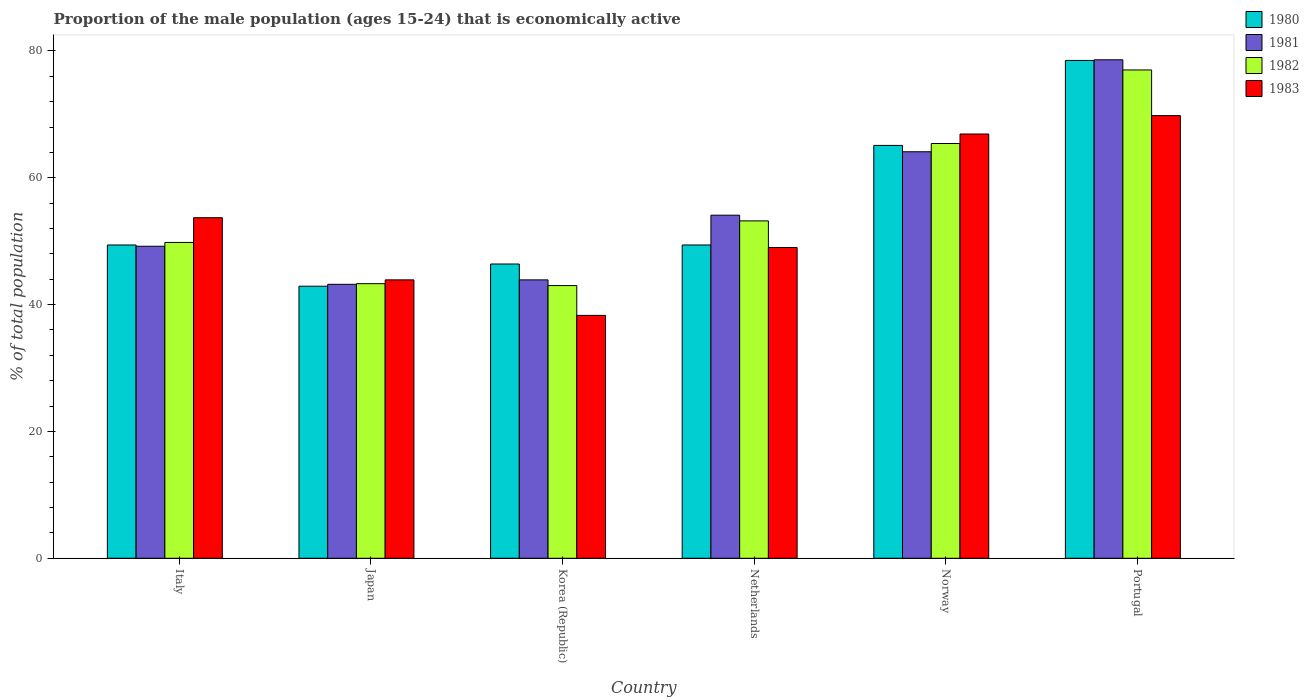How many different coloured bars are there?
Your response must be concise. 4. How many groups of bars are there?
Your answer should be very brief. 6. Are the number of bars per tick equal to the number of legend labels?
Your answer should be very brief. Yes. How many bars are there on the 5th tick from the left?
Provide a short and direct response. 4. How many bars are there on the 1st tick from the right?
Keep it short and to the point. 4. What is the label of the 4th group of bars from the left?
Provide a short and direct response. Netherlands. What is the proportion of the male population that is economically active in 1983 in Korea (Republic)?
Your answer should be very brief. 38.3. Across all countries, what is the maximum proportion of the male population that is economically active in 1982?
Ensure brevity in your answer.  77. Across all countries, what is the minimum proportion of the male population that is economically active in 1981?
Give a very brief answer. 43.2. In which country was the proportion of the male population that is economically active in 1983 maximum?
Offer a very short reply. Portugal. What is the total proportion of the male population that is economically active in 1980 in the graph?
Give a very brief answer. 331.7. What is the difference between the proportion of the male population that is economically active in 1983 in Italy and that in Netherlands?
Provide a succinct answer. 4.7. What is the difference between the proportion of the male population that is economically active in 1981 in Norway and the proportion of the male population that is economically active in 1980 in Netherlands?
Offer a very short reply. 14.7. What is the average proportion of the male population that is economically active in 1981 per country?
Your answer should be very brief. 55.52. What is the difference between the proportion of the male population that is economically active of/in 1981 and proportion of the male population that is economically active of/in 1980 in Portugal?
Give a very brief answer. 0.1. What is the ratio of the proportion of the male population that is economically active in 1983 in Netherlands to that in Portugal?
Provide a short and direct response. 0.7. Is the proportion of the male population that is economically active in 1981 in Netherlands less than that in Norway?
Offer a very short reply. Yes. What is the difference between the highest and the second highest proportion of the male population that is economically active in 1982?
Make the answer very short. 12.2. In how many countries, is the proportion of the male population that is economically active in 1983 greater than the average proportion of the male population that is economically active in 1983 taken over all countries?
Keep it short and to the point. 3. Is the sum of the proportion of the male population that is economically active in 1981 in Italy and Portugal greater than the maximum proportion of the male population that is economically active in 1980 across all countries?
Ensure brevity in your answer.  Yes. What does the 1st bar from the right in Norway represents?
Give a very brief answer. 1983. Is it the case that in every country, the sum of the proportion of the male population that is economically active in 1982 and proportion of the male population that is economically active in 1980 is greater than the proportion of the male population that is economically active in 1981?
Offer a very short reply. Yes. Are all the bars in the graph horizontal?
Make the answer very short. No. What is the difference between two consecutive major ticks on the Y-axis?
Provide a short and direct response. 20. Where does the legend appear in the graph?
Your answer should be very brief. Top right. What is the title of the graph?
Make the answer very short. Proportion of the male population (ages 15-24) that is economically active. Does "2012" appear as one of the legend labels in the graph?
Give a very brief answer. No. What is the label or title of the X-axis?
Your answer should be very brief. Country. What is the label or title of the Y-axis?
Offer a very short reply. % of total population. What is the % of total population of 1980 in Italy?
Offer a very short reply. 49.4. What is the % of total population in 1981 in Italy?
Offer a very short reply. 49.2. What is the % of total population of 1982 in Italy?
Your answer should be very brief. 49.8. What is the % of total population in 1983 in Italy?
Ensure brevity in your answer.  53.7. What is the % of total population in 1980 in Japan?
Provide a succinct answer. 42.9. What is the % of total population in 1981 in Japan?
Ensure brevity in your answer.  43.2. What is the % of total population in 1982 in Japan?
Offer a very short reply. 43.3. What is the % of total population of 1983 in Japan?
Provide a short and direct response. 43.9. What is the % of total population in 1980 in Korea (Republic)?
Your response must be concise. 46.4. What is the % of total population in 1981 in Korea (Republic)?
Ensure brevity in your answer.  43.9. What is the % of total population of 1983 in Korea (Republic)?
Offer a very short reply. 38.3. What is the % of total population in 1980 in Netherlands?
Provide a succinct answer. 49.4. What is the % of total population of 1981 in Netherlands?
Your answer should be compact. 54.1. What is the % of total population in 1982 in Netherlands?
Give a very brief answer. 53.2. What is the % of total population of 1983 in Netherlands?
Your answer should be compact. 49. What is the % of total population in 1980 in Norway?
Offer a terse response. 65.1. What is the % of total population of 1981 in Norway?
Your answer should be compact. 64.1. What is the % of total population of 1982 in Norway?
Your response must be concise. 65.4. What is the % of total population in 1983 in Norway?
Offer a very short reply. 66.9. What is the % of total population in 1980 in Portugal?
Ensure brevity in your answer.  78.5. What is the % of total population in 1981 in Portugal?
Your answer should be very brief. 78.6. What is the % of total population of 1983 in Portugal?
Your response must be concise. 69.8. Across all countries, what is the maximum % of total population in 1980?
Give a very brief answer. 78.5. Across all countries, what is the maximum % of total population in 1981?
Keep it short and to the point. 78.6. Across all countries, what is the maximum % of total population in 1983?
Your answer should be compact. 69.8. Across all countries, what is the minimum % of total population of 1980?
Your answer should be very brief. 42.9. Across all countries, what is the minimum % of total population in 1981?
Your answer should be compact. 43.2. Across all countries, what is the minimum % of total population of 1982?
Ensure brevity in your answer.  43. Across all countries, what is the minimum % of total population of 1983?
Ensure brevity in your answer.  38.3. What is the total % of total population of 1980 in the graph?
Provide a succinct answer. 331.7. What is the total % of total population in 1981 in the graph?
Keep it short and to the point. 333.1. What is the total % of total population of 1982 in the graph?
Give a very brief answer. 331.7. What is the total % of total population of 1983 in the graph?
Your answer should be very brief. 321.6. What is the difference between the % of total population in 1980 in Italy and that in Japan?
Provide a short and direct response. 6.5. What is the difference between the % of total population of 1981 in Italy and that in Japan?
Keep it short and to the point. 6. What is the difference between the % of total population in 1980 in Italy and that in Korea (Republic)?
Offer a terse response. 3. What is the difference between the % of total population in 1981 in Italy and that in Korea (Republic)?
Ensure brevity in your answer.  5.3. What is the difference between the % of total population of 1982 in Italy and that in Korea (Republic)?
Your answer should be very brief. 6.8. What is the difference between the % of total population in 1980 in Italy and that in Netherlands?
Ensure brevity in your answer.  0. What is the difference between the % of total population of 1983 in Italy and that in Netherlands?
Give a very brief answer. 4.7. What is the difference between the % of total population in 1980 in Italy and that in Norway?
Provide a succinct answer. -15.7. What is the difference between the % of total population in 1981 in Italy and that in Norway?
Give a very brief answer. -14.9. What is the difference between the % of total population of 1982 in Italy and that in Norway?
Ensure brevity in your answer.  -15.6. What is the difference between the % of total population of 1980 in Italy and that in Portugal?
Give a very brief answer. -29.1. What is the difference between the % of total population of 1981 in Italy and that in Portugal?
Your answer should be very brief. -29.4. What is the difference between the % of total population in 1982 in Italy and that in Portugal?
Give a very brief answer. -27.2. What is the difference between the % of total population of 1983 in Italy and that in Portugal?
Your answer should be compact. -16.1. What is the difference between the % of total population in 1980 in Japan and that in Korea (Republic)?
Provide a short and direct response. -3.5. What is the difference between the % of total population in 1982 in Japan and that in Korea (Republic)?
Offer a very short reply. 0.3. What is the difference between the % of total population in 1983 in Japan and that in Korea (Republic)?
Make the answer very short. 5.6. What is the difference between the % of total population of 1981 in Japan and that in Netherlands?
Provide a short and direct response. -10.9. What is the difference between the % of total population of 1983 in Japan and that in Netherlands?
Provide a succinct answer. -5.1. What is the difference between the % of total population of 1980 in Japan and that in Norway?
Keep it short and to the point. -22.2. What is the difference between the % of total population in 1981 in Japan and that in Norway?
Make the answer very short. -20.9. What is the difference between the % of total population of 1982 in Japan and that in Norway?
Provide a succinct answer. -22.1. What is the difference between the % of total population of 1983 in Japan and that in Norway?
Offer a very short reply. -23. What is the difference between the % of total population of 1980 in Japan and that in Portugal?
Ensure brevity in your answer.  -35.6. What is the difference between the % of total population of 1981 in Japan and that in Portugal?
Make the answer very short. -35.4. What is the difference between the % of total population in 1982 in Japan and that in Portugal?
Make the answer very short. -33.7. What is the difference between the % of total population in 1983 in Japan and that in Portugal?
Make the answer very short. -25.9. What is the difference between the % of total population in 1981 in Korea (Republic) and that in Netherlands?
Offer a very short reply. -10.2. What is the difference between the % of total population in 1982 in Korea (Republic) and that in Netherlands?
Offer a very short reply. -10.2. What is the difference between the % of total population in 1983 in Korea (Republic) and that in Netherlands?
Offer a terse response. -10.7. What is the difference between the % of total population in 1980 in Korea (Republic) and that in Norway?
Ensure brevity in your answer.  -18.7. What is the difference between the % of total population in 1981 in Korea (Republic) and that in Norway?
Your answer should be compact. -20.2. What is the difference between the % of total population in 1982 in Korea (Republic) and that in Norway?
Offer a terse response. -22.4. What is the difference between the % of total population in 1983 in Korea (Republic) and that in Norway?
Ensure brevity in your answer.  -28.6. What is the difference between the % of total population in 1980 in Korea (Republic) and that in Portugal?
Provide a short and direct response. -32.1. What is the difference between the % of total population of 1981 in Korea (Republic) and that in Portugal?
Keep it short and to the point. -34.7. What is the difference between the % of total population in 1982 in Korea (Republic) and that in Portugal?
Ensure brevity in your answer.  -34. What is the difference between the % of total population of 1983 in Korea (Republic) and that in Portugal?
Ensure brevity in your answer.  -31.5. What is the difference between the % of total population of 1980 in Netherlands and that in Norway?
Your answer should be very brief. -15.7. What is the difference between the % of total population of 1981 in Netherlands and that in Norway?
Provide a short and direct response. -10. What is the difference between the % of total population of 1982 in Netherlands and that in Norway?
Your response must be concise. -12.2. What is the difference between the % of total population of 1983 in Netherlands and that in Norway?
Keep it short and to the point. -17.9. What is the difference between the % of total population of 1980 in Netherlands and that in Portugal?
Make the answer very short. -29.1. What is the difference between the % of total population in 1981 in Netherlands and that in Portugal?
Provide a succinct answer. -24.5. What is the difference between the % of total population in 1982 in Netherlands and that in Portugal?
Provide a succinct answer. -23.8. What is the difference between the % of total population of 1983 in Netherlands and that in Portugal?
Provide a short and direct response. -20.8. What is the difference between the % of total population in 1980 in Norway and that in Portugal?
Your response must be concise. -13.4. What is the difference between the % of total population of 1981 in Norway and that in Portugal?
Ensure brevity in your answer.  -14.5. What is the difference between the % of total population in 1982 in Norway and that in Portugal?
Your answer should be very brief. -11.6. What is the difference between the % of total population in 1983 in Norway and that in Portugal?
Keep it short and to the point. -2.9. What is the difference between the % of total population of 1980 in Italy and the % of total population of 1981 in Japan?
Offer a terse response. 6.2. What is the difference between the % of total population of 1980 in Italy and the % of total population of 1982 in Japan?
Your answer should be very brief. 6.1. What is the difference between the % of total population of 1981 in Italy and the % of total population of 1982 in Japan?
Offer a very short reply. 5.9. What is the difference between the % of total population in 1980 in Italy and the % of total population in 1981 in Korea (Republic)?
Keep it short and to the point. 5.5. What is the difference between the % of total population in 1980 in Italy and the % of total population in 1983 in Korea (Republic)?
Your answer should be compact. 11.1. What is the difference between the % of total population in 1981 in Italy and the % of total population in 1982 in Korea (Republic)?
Your response must be concise. 6.2. What is the difference between the % of total population of 1980 in Italy and the % of total population of 1981 in Netherlands?
Provide a succinct answer. -4.7. What is the difference between the % of total population in 1980 in Italy and the % of total population in 1982 in Netherlands?
Offer a terse response. -3.8. What is the difference between the % of total population of 1981 in Italy and the % of total population of 1982 in Netherlands?
Your answer should be very brief. -4. What is the difference between the % of total population of 1982 in Italy and the % of total population of 1983 in Netherlands?
Your answer should be very brief. 0.8. What is the difference between the % of total population of 1980 in Italy and the % of total population of 1981 in Norway?
Your answer should be compact. -14.7. What is the difference between the % of total population of 1980 in Italy and the % of total population of 1982 in Norway?
Keep it short and to the point. -16. What is the difference between the % of total population in 1980 in Italy and the % of total population in 1983 in Norway?
Provide a short and direct response. -17.5. What is the difference between the % of total population in 1981 in Italy and the % of total population in 1982 in Norway?
Your answer should be compact. -16.2. What is the difference between the % of total population of 1981 in Italy and the % of total population of 1983 in Norway?
Provide a succinct answer. -17.7. What is the difference between the % of total population in 1982 in Italy and the % of total population in 1983 in Norway?
Ensure brevity in your answer.  -17.1. What is the difference between the % of total population in 1980 in Italy and the % of total population in 1981 in Portugal?
Make the answer very short. -29.2. What is the difference between the % of total population of 1980 in Italy and the % of total population of 1982 in Portugal?
Your answer should be very brief. -27.6. What is the difference between the % of total population of 1980 in Italy and the % of total population of 1983 in Portugal?
Offer a very short reply. -20.4. What is the difference between the % of total population in 1981 in Italy and the % of total population in 1982 in Portugal?
Give a very brief answer. -27.8. What is the difference between the % of total population in 1981 in Italy and the % of total population in 1983 in Portugal?
Ensure brevity in your answer.  -20.6. What is the difference between the % of total population in 1980 in Japan and the % of total population in 1981 in Korea (Republic)?
Your response must be concise. -1. What is the difference between the % of total population of 1980 in Japan and the % of total population of 1982 in Korea (Republic)?
Make the answer very short. -0.1. What is the difference between the % of total population in 1981 in Japan and the % of total population in 1983 in Korea (Republic)?
Ensure brevity in your answer.  4.9. What is the difference between the % of total population in 1980 in Japan and the % of total population in 1982 in Netherlands?
Give a very brief answer. -10.3. What is the difference between the % of total population of 1980 in Japan and the % of total population of 1983 in Netherlands?
Your answer should be compact. -6.1. What is the difference between the % of total population of 1982 in Japan and the % of total population of 1983 in Netherlands?
Your answer should be very brief. -5.7. What is the difference between the % of total population of 1980 in Japan and the % of total population of 1981 in Norway?
Provide a short and direct response. -21.2. What is the difference between the % of total population of 1980 in Japan and the % of total population of 1982 in Norway?
Provide a short and direct response. -22.5. What is the difference between the % of total population in 1980 in Japan and the % of total population in 1983 in Norway?
Offer a terse response. -24. What is the difference between the % of total population of 1981 in Japan and the % of total population of 1982 in Norway?
Provide a succinct answer. -22.2. What is the difference between the % of total population of 1981 in Japan and the % of total population of 1983 in Norway?
Offer a terse response. -23.7. What is the difference between the % of total population in 1982 in Japan and the % of total population in 1983 in Norway?
Your answer should be very brief. -23.6. What is the difference between the % of total population in 1980 in Japan and the % of total population in 1981 in Portugal?
Offer a very short reply. -35.7. What is the difference between the % of total population of 1980 in Japan and the % of total population of 1982 in Portugal?
Your answer should be compact. -34.1. What is the difference between the % of total population of 1980 in Japan and the % of total population of 1983 in Portugal?
Your answer should be compact. -26.9. What is the difference between the % of total population in 1981 in Japan and the % of total population in 1982 in Portugal?
Your answer should be very brief. -33.8. What is the difference between the % of total population of 1981 in Japan and the % of total population of 1983 in Portugal?
Offer a terse response. -26.6. What is the difference between the % of total population of 1982 in Japan and the % of total population of 1983 in Portugal?
Keep it short and to the point. -26.5. What is the difference between the % of total population in 1980 in Korea (Republic) and the % of total population in 1981 in Netherlands?
Your answer should be compact. -7.7. What is the difference between the % of total population of 1981 in Korea (Republic) and the % of total population of 1983 in Netherlands?
Your answer should be compact. -5.1. What is the difference between the % of total population in 1980 in Korea (Republic) and the % of total population in 1981 in Norway?
Ensure brevity in your answer.  -17.7. What is the difference between the % of total population of 1980 in Korea (Republic) and the % of total population of 1982 in Norway?
Give a very brief answer. -19. What is the difference between the % of total population in 1980 in Korea (Republic) and the % of total population in 1983 in Norway?
Provide a succinct answer. -20.5. What is the difference between the % of total population in 1981 in Korea (Republic) and the % of total population in 1982 in Norway?
Provide a succinct answer. -21.5. What is the difference between the % of total population of 1981 in Korea (Republic) and the % of total population of 1983 in Norway?
Your answer should be compact. -23. What is the difference between the % of total population of 1982 in Korea (Republic) and the % of total population of 1983 in Norway?
Your answer should be very brief. -23.9. What is the difference between the % of total population of 1980 in Korea (Republic) and the % of total population of 1981 in Portugal?
Provide a succinct answer. -32.2. What is the difference between the % of total population in 1980 in Korea (Republic) and the % of total population in 1982 in Portugal?
Keep it short and to the point. -30.6. What is the difference between the % of total population of 1980 in Korea (Republic) and the % of total population of 1983 in Portugal?
Your answer should be very brief. -23.4. What is the difference between the % of total population of 1981 in Korea (Republic) and the % of total population of 1982 in Portugal?
Your response must be concise. -33.1. What is the difference between the % of total population in 1981 in Korea (Republic) and the % of total population in 1983 in Portugal?
Your response must be concise. -25.9. What is the difference between the % of total population of 1982 in Korea (Republic) and the % of total population of 1983 in Portugal?
Your response must be concise. -26.8. What is the difference between the % of total population of 1980 in Netherlands and the % of total population of 1981 in Norway?
Ensure brevity in your answer.  -14.7. What is the difference between the % of total population of 1980 in Netherlands and the % of total population of 1983 in Norway?
Provide a succinct answer. -17.5. What is the difference between the % of total population of 1981 in Netherlands and the % of total population of 1982 in Norway?
Provide a succinct answer. -11.3. What is the difference between the % of total population of 1981 in Netherlands and the % of total population of 1983 in Norway?
Keep it short and to the point. -12.8. What is the difference between the % of total population of 1982 in Netherlands and the % of total population of 1983 in Norway?
Ensure brevity in your answer.  -13.7. What is the difference between the % of total population of 1980 in Netherlands and the % of total population of 1981 in Portugal?
Make the answer very short. -29.2. What is the difference between the % of total population in 1980 in Netherlands and the % of total population in 1982 in Portugal?
Give a very brief answer. -27.6. What is the difference between the % of total population in 1980 in Netherlands and the % of total population in 1983 in Portugal?
Your answer should be very brief. -20.4. What is the difference between the % of total population in 1981 in Netherlands and the % of total population in 1982 in Portugal?
Give a very brief answer. -22.9. What is the difference between the % of total population in 1981 in Netherlands and the % of total population in 1983 in Portugal?
Your response must be concise. -15.7. What is the difference between the % of total population in 1982 in Netherlands and the % of total population in 1983 in Portugal?
Offer a terse response. -16.6. What is the difference between the % of total population in 1981 in Norway and the % of total population in 1982 in Portugal?
Give a very brief answer. -12.9. What is the difference between the % of total population of 1981 in Norway and the % of total population of 1983 in Portugal?
Keep it short and to the point. -5.7. What is the difference between the % of total population of 1982 in Norway and the % of total population of 1983 in Portugal?
Make the answer very short. -4.4. What is the average % of total population of 1980 per country?
Give a very brief answer. 55.28. What is the average % of total population of 1981 per country?
Provide a succinct answer. 55.52. What is the average % of total population in 1982 per country?
Ensure brevity in your answer.  55.28. What is the average % of total population of 1983 per country?
Offer a very short reply. 53.6. What is the difference between the % of total population in 1980 and % of total population in 1982 in Italy?
Your response must be concise. -0.4. What is the difference between the % of total population in 1980 and % of total population in 1983 in Italy?
Make the answer very short. -4.3. What is the difference between the % of total population in 1980 and % of total population in 1982 in Japan?
Your response must be concise. -0.4. What is the difference between the % of total population in 1980 and % of total population in 1983 in Japan?
Provide a succinct answer. -1. What is the difference between the % of total population of 1981 and % of total population of 1983 in Japan?
Your response must be concise. -0.7. What is the difference between the % of total population in 1980 and % of total population in 1982 in Korea (Republic)?
Keep it short and to the point. 3.4. What is the difference between the % of total population of 1981 and % of total population of 1982 in Korea (Republic)?
Your response must be concise. 0.9. What is the difference between the % of total population in 1982 and % of total population in 1983 in Korea (Republic)?
Offer a terse response. 4.7. What is the difference between the % of total population of 1980 and % of total population of 1981 in Netherlands?
Offer a terse response. -4.7. What is the difference between the % of total population of 1980 and % of total population of 1982 in Netherlands?
Provide a short and direct response. -3.8. What is the difference between the % of total population in 1980 and % of total population in 1983 in Netherlands?
Offer a very short reply. 0.4. What is the difference between the % of total population of 1981 and % of total population of 1982 in Netherlands?
Your response must be concise. 0.9. What is the difference between the % of total population of 1981 and % of total population of 1983 in Netherlands?
Make the answer very short. 5.1. What is the difference between the % of total population in 1980 and % of total population in 1982 in Norway?
Your response must be concise. -0.3. What is the difference between the % of total population of 1980 and % of total population of 1983 in Norway?
Provide a succinct answer. -1.8. What is the difference between the % of total population of 1981 and % of total population of 1982 in Norway?
Your answer should be very brief. -1.3. What is the difference between the % of total population of 1981 and % of total population of 1983 in Norway?
Your response must be concise. -2.8. What is the difference between the % of total population in 1982 and % of total population in 1983 in Norway?
Your answer should be very brief. -1.5. What is the difference between the % of total population of 1980 and % of total population of 1981 in Portugal?
Ensure brevity in your answer.  -0.1. What is the difference between the % of total population in 1980 and % of total population in 1982 in Portugal?
Your answer should be compact. 1.5. What is the difference between the % of total population of 1980 and % of total population of 1983 in Portugal?
Give a very brief answer. 8.7. What is the difference between the % of total population in 1981 and % of total population in 1982 in Portugal?
Provide a short and direct response. 1.6. What is the difference between the % of total population of 1981 and % of total population of 1983 in Portugal?
Your response must be concise. 8.8. What is the difference between the % of total population of 1982 and % of total population of 1983 in Portugal?
Make the answer very short. 7.2. What is the ratio of the % of total population in 1980 in Italy to that in Japan?
Provide a short and direct response. 1.15. What is the ratio of the % of total population of 1981 in Italy to that in Japan?
Offer a very short reply. 1.14. What is the ratio of the % of total population in 1982 in Italy to that in Japan?
Your answer should be very brief. 1.15. What is the ratio of the % of total population of 1983 in Italy to that in Japan?
Offer a terse response. 1.22. What is the ratio of the % of total population of 1980 in Italy to that in Korea (Republic)?
Your response must be concise. 1.06. What is the ratio of the % of total population of 1981 in Italy to that in Korea (Republic)?
Offer a very short reply. 1.12. What is the ratio of the % of total population in 1982 in Italy to that in Korea (Republic)?
Make the answer very short. 1.16. What is the ratio of the % of total population in 1983 in Italy to that in Korea (Republic)?
Offer a terse response. 1.4. What is the ratio of the % of total population in 1980 in Italy to that in Netherlands?
Your response must be concise. 1. What is the ratio of the % of total population of 1981 in Italy to that in Netherlands?
Your answer should be very brief. 0.91. What is the ratio of the % of total population of 1982 in Italy to that in Netherlands?
Your answer should be very brief. 0.94. What is the ratio of the % of total population in 1983 in Italy to that in Netherlands?
Ensure brevity in your answer.  1.1. What is the ratio of the % of total population in 1980 in Italy to that in Norway?
Your response must be concise. 0.76. What is the ratio of the % of total population of 1981 in Italy to that in Norway?
Keep it short and to the point. 0.77. What is the ratio of the % of total population of 1982 in Italy to that in Norway?
Give a very brief answer. 0.76. What is the ratio of the % of total population in 1983 in Italy to that in Norway?
Your answer should be compact. 0.8. What is the ratio of the % of total population in 1980 in Italy to that in Portugal?
Your response must be concise. 0.63. What is the ratio of the % of total population of 1981 in Italy to that in Portugal?
Ensure brevity in your answer.  0.63. What is the ratio of the % of total population in 1982 in Italy to that in Portugal?
Offer a very short reply. 0.65. What is the ratio of the % of total population in 1983 in Italy to that in Portugal?
Your answer should be very brief. 0.77. What is the ratio of the % of total population in 1980 in Japan to that in Korea (Republic)?
Your response must be concise. 0.92. What is the ratio of the % of total population in 1981 in Japan to that in Korea (Republic)?
Keep it short and to the point. 0.98. What is the ratio of the % of total population in 1982 in Japan to that in Korea (Republic)?
Provide a short and direct response. 1.01. What is the ratio of the % of total population in 1983 in Japan to that in Korea (Republic)?
Ensure brevity in your answer.  1.15. What is the ratio of the % of total population in 1980 in Japan to that in Netherlands?
Your answer should be compact. 0.87. What is the ratio of the % of total population in 1981 in Japan to that in Netherlands?
Your answer should be compact. 0.8. What is the ratio of the % of total population in 1982 in Japan to that in Netherlands?
Your answer should be compact. 0.81. What is the ratio of the % of total population of 1983 in Japan to that in Netherlands?
Your answer should be very brief. 0.9. What is the ratio of the % of total population of 1980 in Japan to that in Norway?
Give a very brief answer. 0.66. What is the ratio of the % of total population in 1981 in Japan to that in Norway?
Offer a very short reply. 0.67. What is the ratio of the % of total population in 1982 in Japan to that in Norway?
Offer a very short reply. 0.66. What is the ratio of the % of total population of 1983 in Japan to that in Norway?
Provide a short and direct response. 0.66. What is the ratio of the % of total population in 1980 in Japan to that in Portugal?
Offer a very short reply. 0.55. What is the ratio of the % of total population of 1981 in Japan to that in Portugal?
Your response must be concise. 0.55. What is the ratio of the % of total population in 1982 in Japan to that in Portugal?
Keep it short and to the point. 0.56. What is the ratio of the % of total population of 1983 in Japan to that in Portugal?
Ensure brevity in your answer.  0.63. What is the ratio of the % of total population in 1980 in Korea (Republic) to that in Netherlands?
Ensure brevity in your answer.  0.94. What is the ratio of the % of total population in 1981 in Korea (Republic) to that in Netherlands?
Give a very brief answer. 0.81. What is the ratio of the % of total population of 1982 in Korea (Republic) to that in Netherlands?
Provide a short and direct response. 0.81. What is the ratio of the % of total population of 1983 in Korea (Republic) to that in Netherlands?
Your response must be concise. 0.78. What is the ratio of the % of total population of 1980 in Korea (Republic) to that in Norway?
Offer a very short reply. 0.71. What is the ratio of the % of total population in 1981 in Korea (Republic) to that in Norway?
Provide a short and direct response. 0.68. What is the ratio of the % of total population in 1982 in Korea (Republic) to that in Norway?
Your response must be concise. 0.66. What is the ratio of the % of total population in 1983 in Korea (Republic) to that in Norway?
Keep it short and to the point. 0.57. What is the ratio of the % of total population in 1980 in Korea (Republic) to that in Portugal?
Make the answer very short. 0.59. What is the ratio of the % of total population in 1981 in Korea (Republic) to that in Portugal?
Offer a very short reply. 0.56. What is the ratio of the % of total population in 1982 in Korea (Republic) to that in Portugal?
Make the answer very short. 0.56. What is the ratio of the % of total population in 1983 in Korea (Republic) to that in Portugal?
Offer a terse response. 0.55. What is the ratio of the % of total population of 1980 in Netherlands to that in Norway?
Provide a short and direct response. 0.76. What is the ratio of the % of total population in 1981 in Netherlands to that in Norway?
Offer a very short reply. 0.84. What is the ratio of the % of total population of 1982 in Netherlands to that in Norway?
Provide a succinct answer. 0.81. What is the ratio of the % of total population in 1983 in Netherlands to that in Norway?
Provide a succinct answer. 0.73. What is the ratio of the % of total population of 1980 in Netherlands to that in Portugal?
Your answer should be compact. 0.63. What is the ratio of the % of total population of 1981 in Netherlands to that in Portugal?
Provide a short and direct response. 0.69. What is the ratio of the % of total population of 1982 in Netherlands to that in Portugal?
Your answer should be very brief. 0.69. What is the ratio of the % of total population of 1983 in Netherlands to that in Portugal?
Your answer should be very brief. 0.7. What is the ratio of the % of total population in 1980 in Norway to that in Portugal?
Your response must be concise. 0.83. What is the ratio of the % of total population of 1981 in Norway to that in Portugal?
Your answer should be very brief. 0.82. What is the ratio of the % of total population of 1982 in Norway to that in Portugal?
Provide a short and direct response. 0.85. What is the ratio of the % of total population in 1983 in Norway to that in Portugal?
Ensure brevity in your answer.  0.96. What is the difference between the highest and the second highest % of total population of 1980?
Provide a short and direct response. 13.4. What is the difference between the highest and the second highest % of total population in 1983?
Give a very brief answer. 2.9. What is the difference between the highest and the lowest % of total population of 1980?
Make the answer very short. 35.6. What is the difference between the highest and the lowest % of total population of 1981?
Your response must be concise. 35.4. What is the difference between the highest and the lowest % of total population of 1983?
Keep it short and to the point. 31.5. 